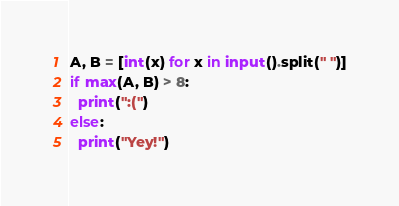<code> <loc_0><loc_0><loc_500><loc_500><_Python_>A, B = [int(x) for x in input().split(" ")]
if max(A, B) > 8:
  print(":(")
else:
  print("Yey!")</code> 